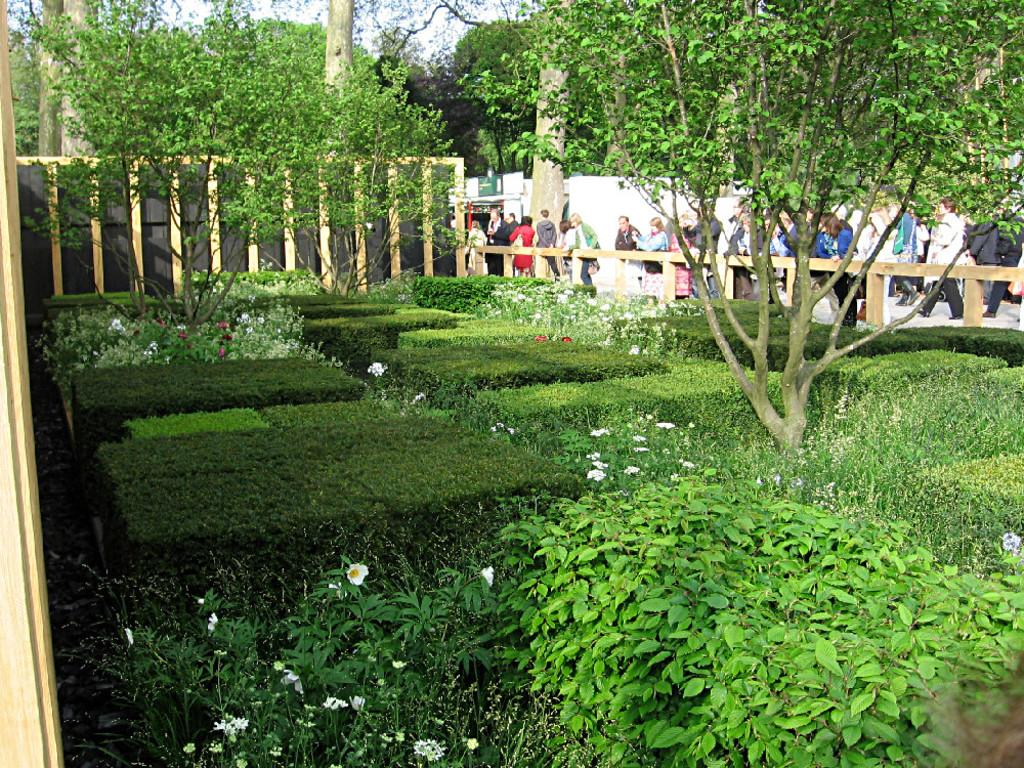What type of vegetation is on the left side of the image? There are many plants and trees on the left side of the image. What can be seen on the right side of the image? There is a road on the right side of the image. What is beside the road? There is a fence beside the road. What are the people in the image doing? There are people walking on the road. Can you tell me how many dimes are scattered on the road in the image? There are no dimes present in the image; it features plants and trees on the left side, a road and fence on the right side, and people walking on the road. What type of whip is being used by the people walking on the road? There is no whip present in the image; the people are simply walking on the road. 